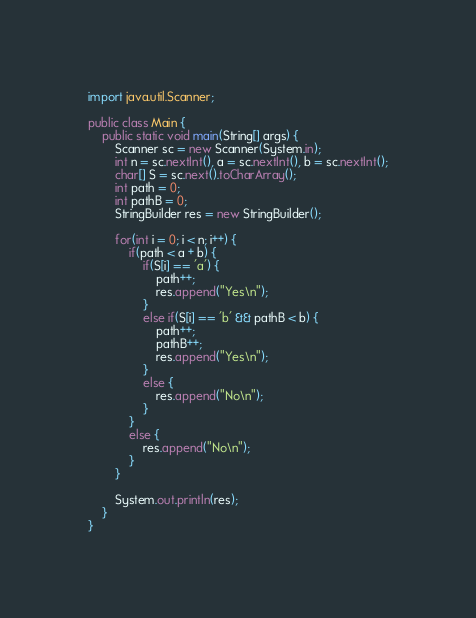<code> <loc_0><loc_0><loc_500><loc_500><_Java_>import java.util.Scanner;

public class Main {
    public static void main(String[] args) {
        Scanner sc = new Scanner(System.in);
        int n = sc.nextInt(), a = sc.nextInt(), b = sc.nextInt();
        char[] S = sc.next().toCharArray();
        int path = 0;
        int pathB = 0;
        StringBuilder res = new StringBuilder();

        for(int i = 0; i < n; i++) {
            if(path < a + b) {
                if(S[i] == 'a') {
                    path++;
                    res.append("Yes\n");
                }
                else if(S[i] == 'b' && pathB < b) {
                    path++;
                    pathB++;
                    res.append("Yes\n");
                }
                else {
                    res.append("No\n");
                }
            }
            else {
                res.append("No\n");
            }
        }

        System.out.println(res);
    }
}
</code> 